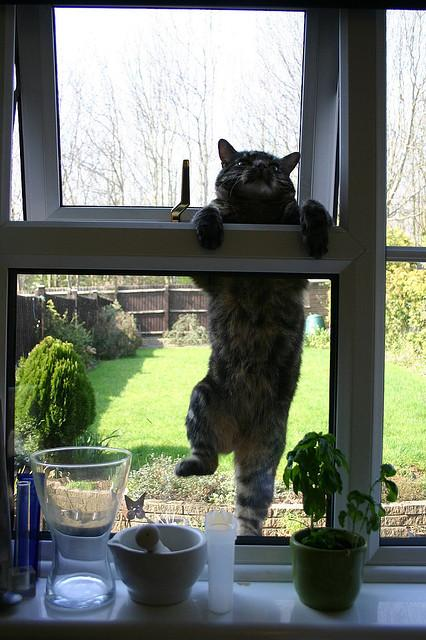What is the cat climbing through? Please explain your reasoning. window. You can tell by the setting and area of the house as to what the cat is climbing on. 